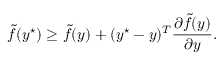<formula> <loc_0><loc_0><loc_500><loc_500>\tilde { f } ( y ^ { ^ { * } } ) \geq \tilde { f } ( y ) + ( y ^ { ^ { * } } - y ) ^ { T } \frac { \partial \tilde { f } ( y ) } { \partial y } .</formula> 